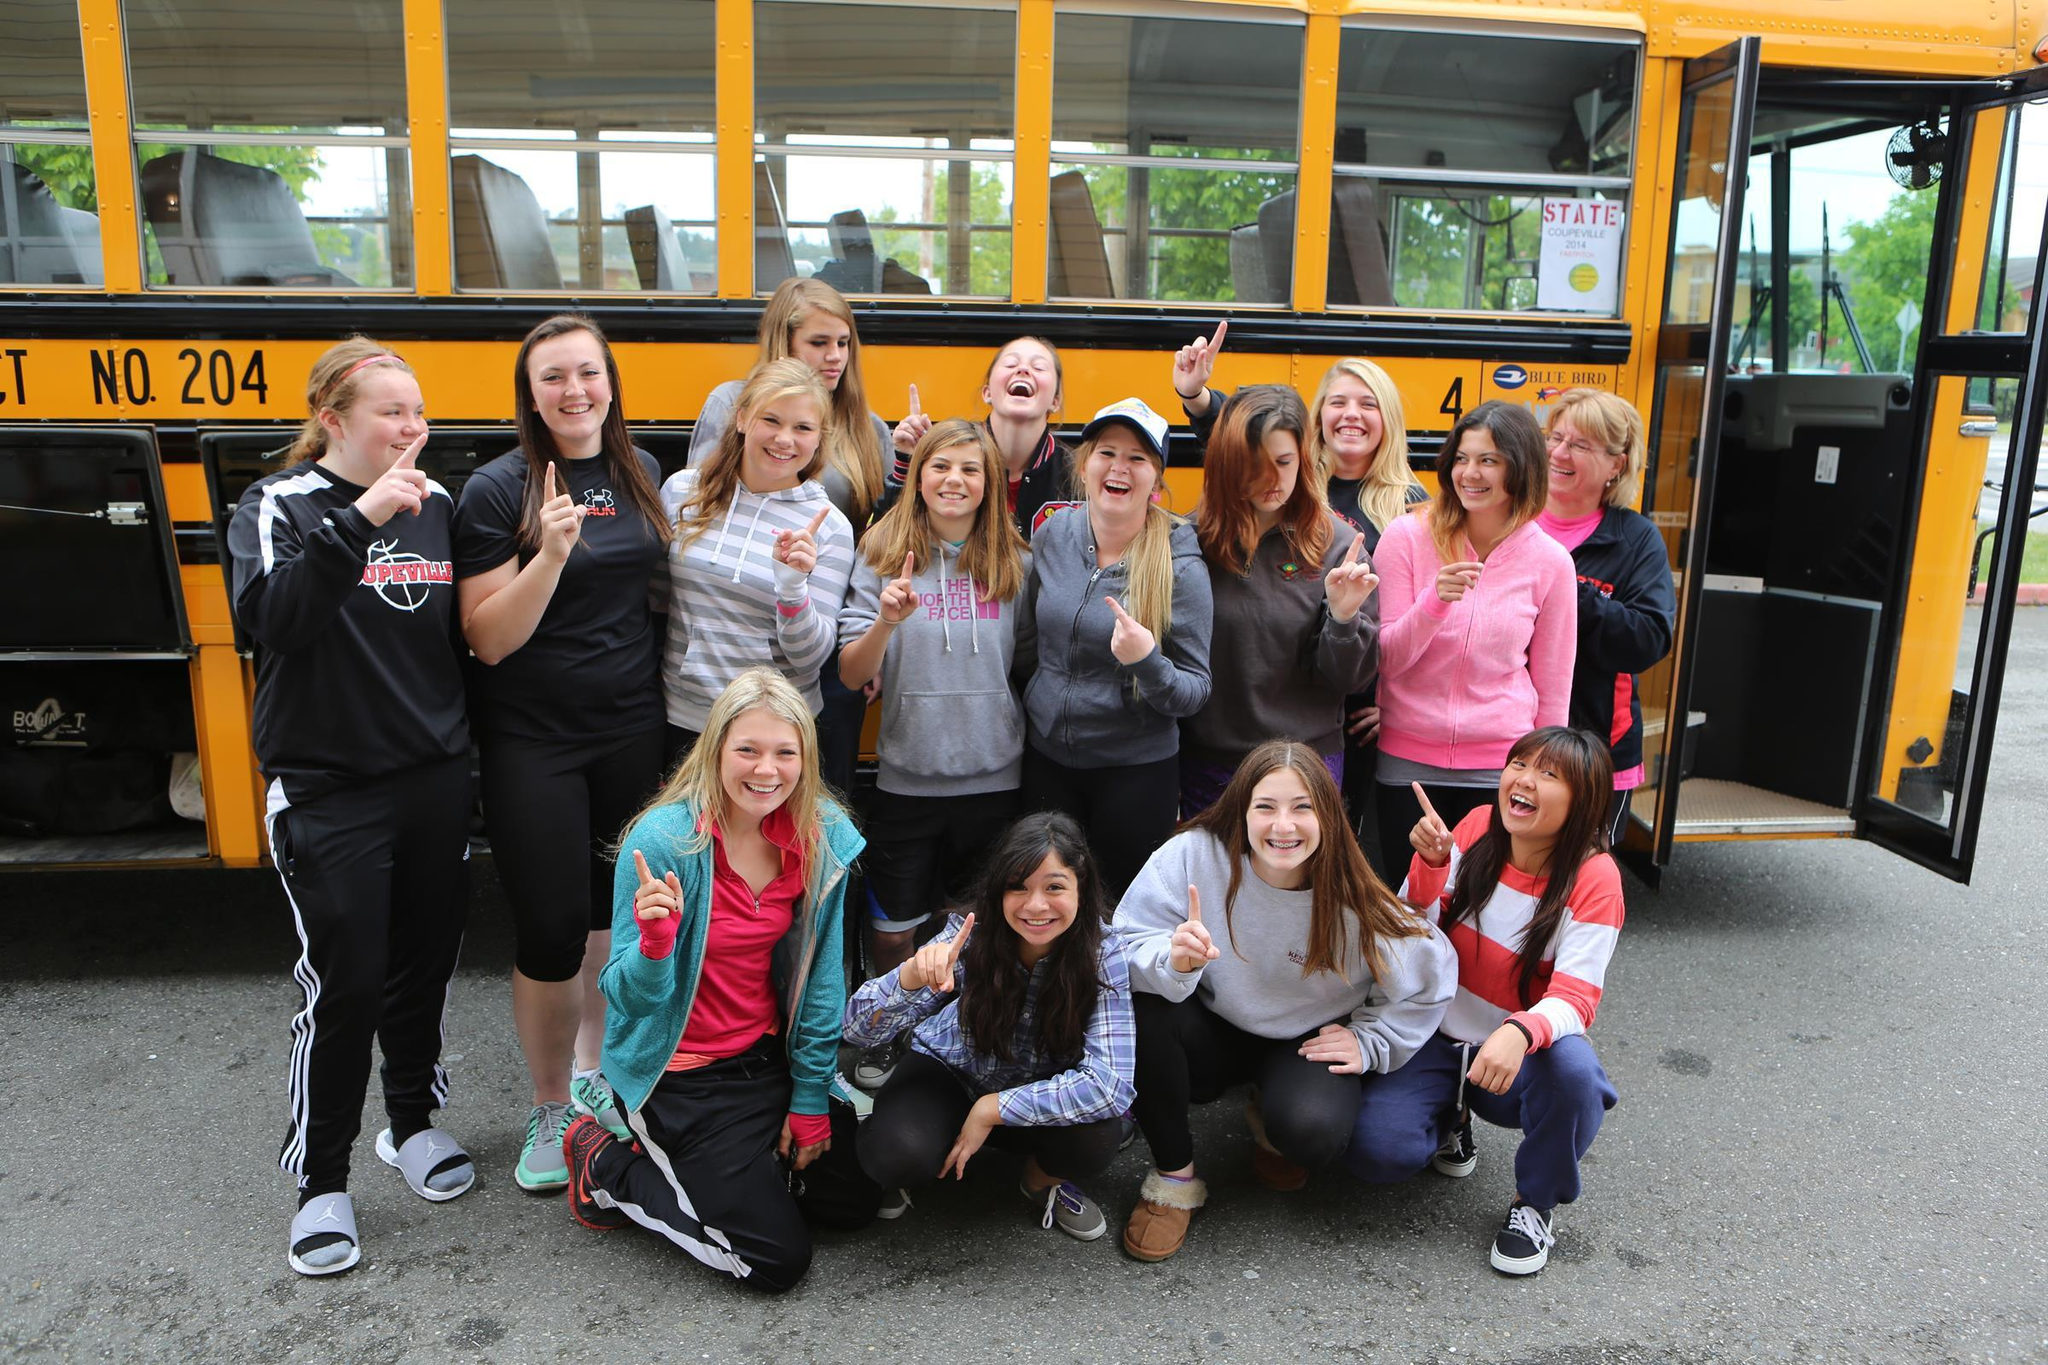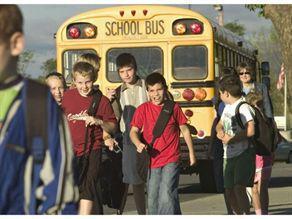The first image is the image on the left, the second image is the image on the right. Evaluate the accuracy of this statement regarding the images: "Each image shows children facing the camera and standing side-by-side in at least one horizontal line in front of the entry-door side of the bus.". Is it true? Answer yes or no. No. The first image is the image on the left, the second image is the image on the right. Evaluate the accuracy of this statement regarding the images: "In the left image there is a group of kids standing in front of a school bus, and the front end of the bus is visible.". Is it true? Answer yes or no. No. 